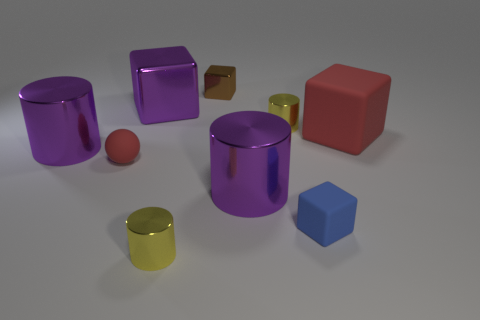What is the size of the sphere that is the same color as the big rubber block?
Offer a very short reply. Small. What material is the purple block?
Provide a succinct answer. Metal. What is the shape of the matte object that is the same color as the tiny ball?
Make the answer very short. Cube. What is the big object that is right of the large purple block and in front of the red rubber cube made of?
Ensure brevity in your answer.  Metal. Is there another blue object of the same shape as the large matte object?
Give a very brief answer. Yes. How many purple metallic objects are behind the large metal cylinder left of the big metallic object that is on the right side of the purple cube?
Ensure brevity in your answer.  1. There is a matte sphere; is it the same color as the large rubber object that is on the right side of the tiny red matte object?
Your answer should be very brief. Yes. What number of things are either metal cylinders that are in front of the tiny red matte object or purple metallic cylinders on the right side of the purple block?
Provide a succinct answer. 2. Are there more purple shiny things in front of the tiny ball than small red matte spheres that are right of the tiny blue block?
Offer a very short reply. Yes. What is the material of the yellow thing left of the large cylinder that is right of the small yellow object that is left of the tiny metallic cube?
Offer a very short reply. Metal. 